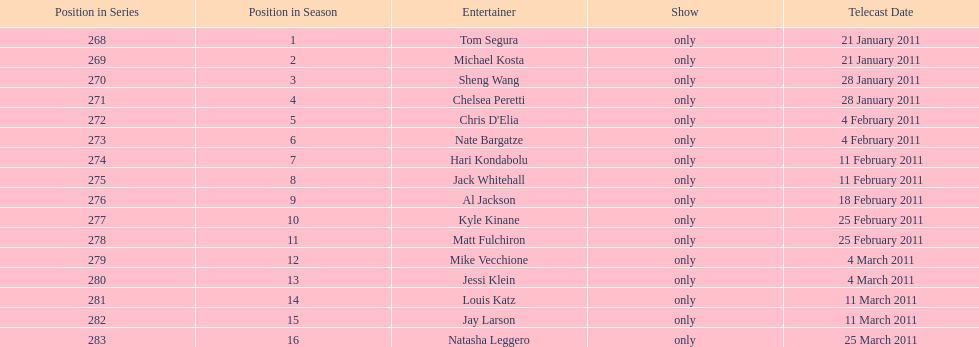Which month had the most air dates? February. 